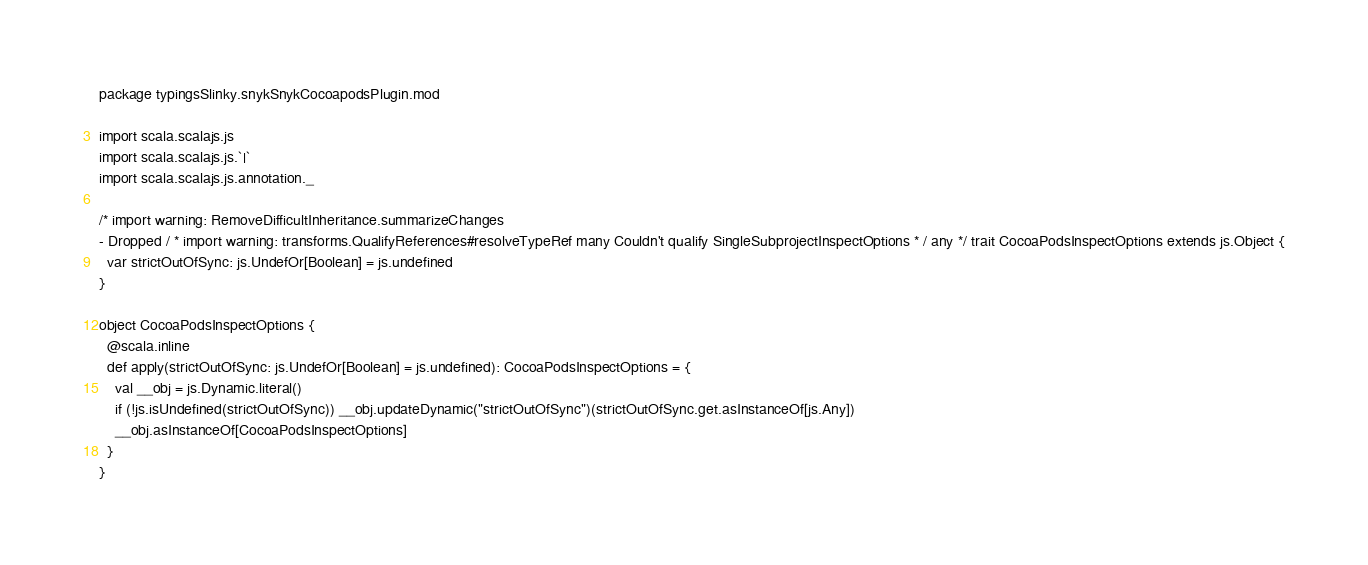Convert code to text. <code><loc_0><loc_0><loc_500><loc_500><_Scala_>package typingsSlinky.snykSnykCocoapodsPlugin.mod

import scala.scalajs.js
import scala.scalajs.js.`|`
import scala.scalajs.js.annotation._

/* import warning: RemoveDifficultInheritance.summarizeChanges 
- Dropped / * import warning: transforms.QualifyReferences#resolveTypeRef many Couldn't qualify SingleSubprojectInspectOptions * / any */ trait CocoaPodsInspectOptions extends js.Object {
  var strictOutOfSync: js.UndefOr[Boolean] = js.undefined
}

object CocoaPodsInspectOptions {
  @scala.inline
  def apply(strictOutOfSync: js.UndefOr[Boolean] = js.undefined): CocoaPodsInspectOptions = {
    val __obj = js.Dynamic.literal()
    if (!js.isUndefined(strictOutOfSync)) __obj.updateDynamic("strictOutOfSync")(strictOutOfSync.get.asInstanceOf[js.Any])
    __obj.asInstanceOf[CocoaPodsInspectOptions]
  }
}

</code> 